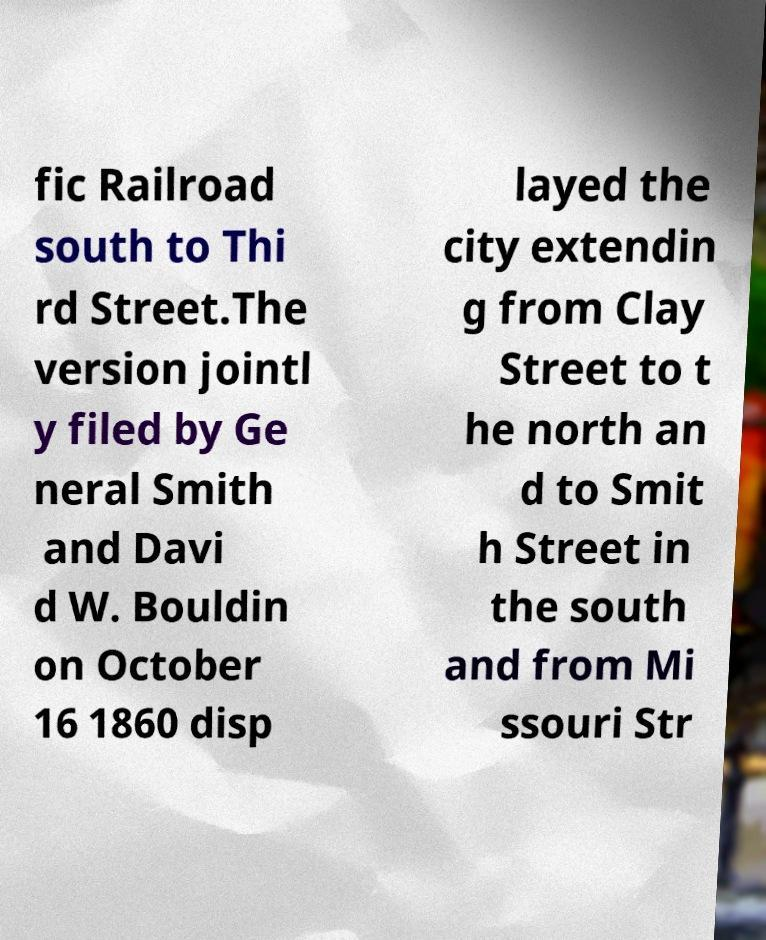Can you read and provide the text displayed in the image?This photo seems to have some interesting text. Can you extract and type it out for me? fic Railroad south to Thi rd Street.The version jointl y filed by Ge neral Smith and Davi d W. Bouldin on October 16 1860 disp layed the city extendin g from Clay Street to t he north an d to Smit h Street in the south and from Mi ssouri Str 